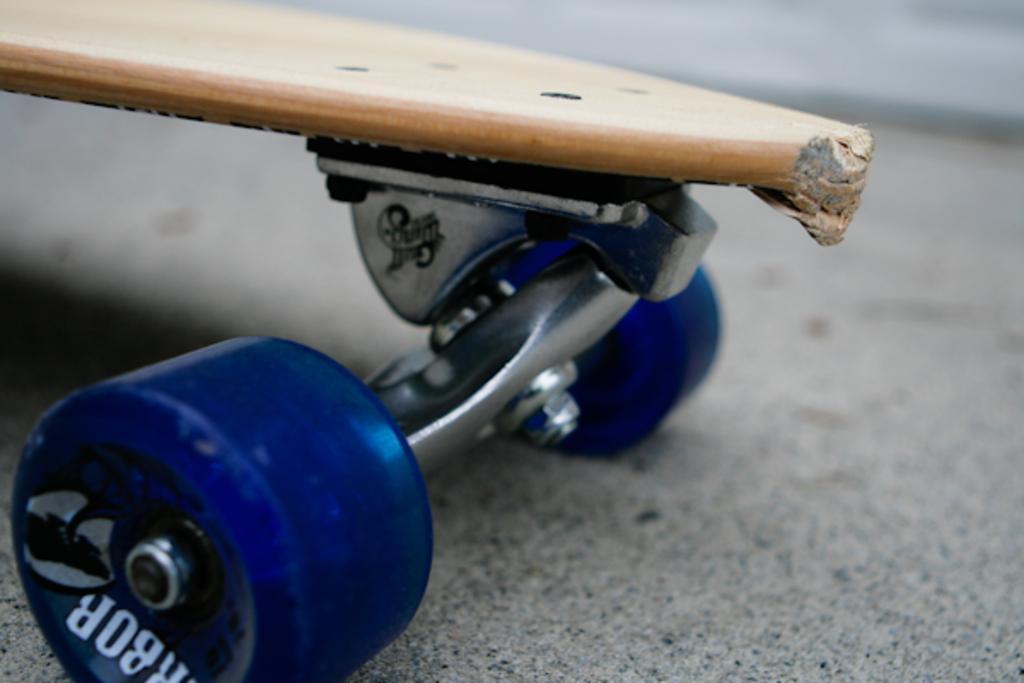In one or two sentences, can you explain what this image depicts? In this image we can see a skateboard. 